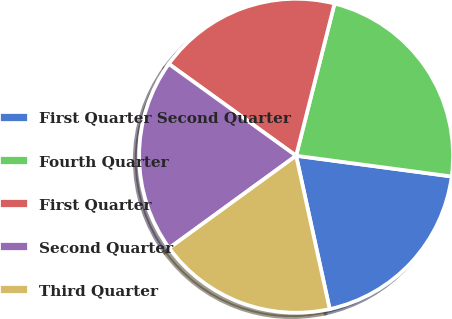Convert chart. <chart><loc_0><loc_0><loc_500><loc_500><pie_chart><fcel>First Quarter Second Quarter<fcel>Fourth Quarter<fcel>First Quarter<fcel>Second Quarter<fcel>Third Quarter<nl><fcel>19.46%<fcel>23.17%<fcel>18.99%<fcel>19.96%<fcel>18.42%<nl></chart> 